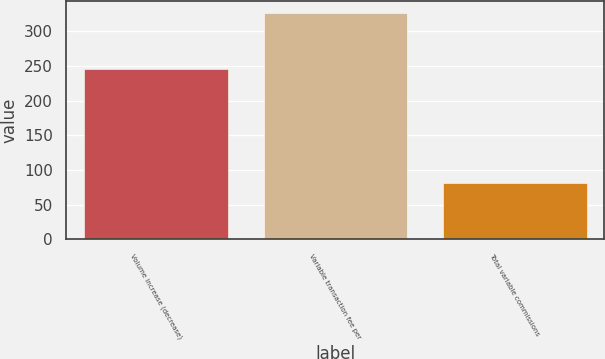Convert chart to OTSL. <chart><loc_0><loc_0><loc_500><loc_500><bar_chart><fcel>Volume increase (decrease)<fcel>Variable transaction fee per<fcel>Total variable commissions<nl><fcel>246<fcel>327<fcel>81<nl></chart> 